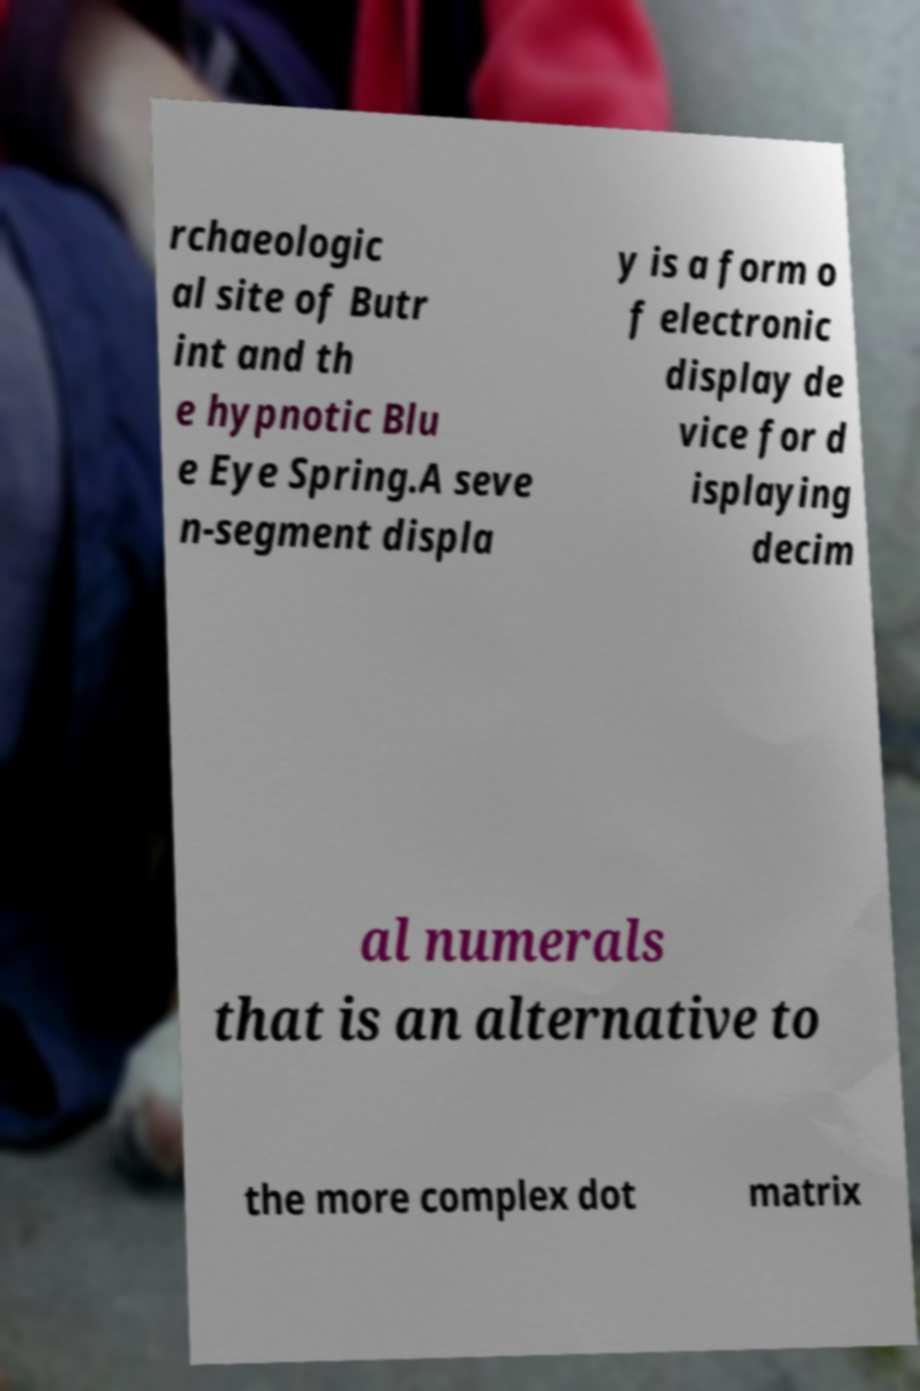Can you read and provide the text displayed in the image?This photo seems to have some interesting text. Can you extract and type it out for me? rchaeologic al site of Butr int and th e hypnotic Blu e Eye Spring.A seve n-segment displa y is a form o f electronic display de vice for d isplaying decim al numerals that is an alternative to the more complex dot matrix 